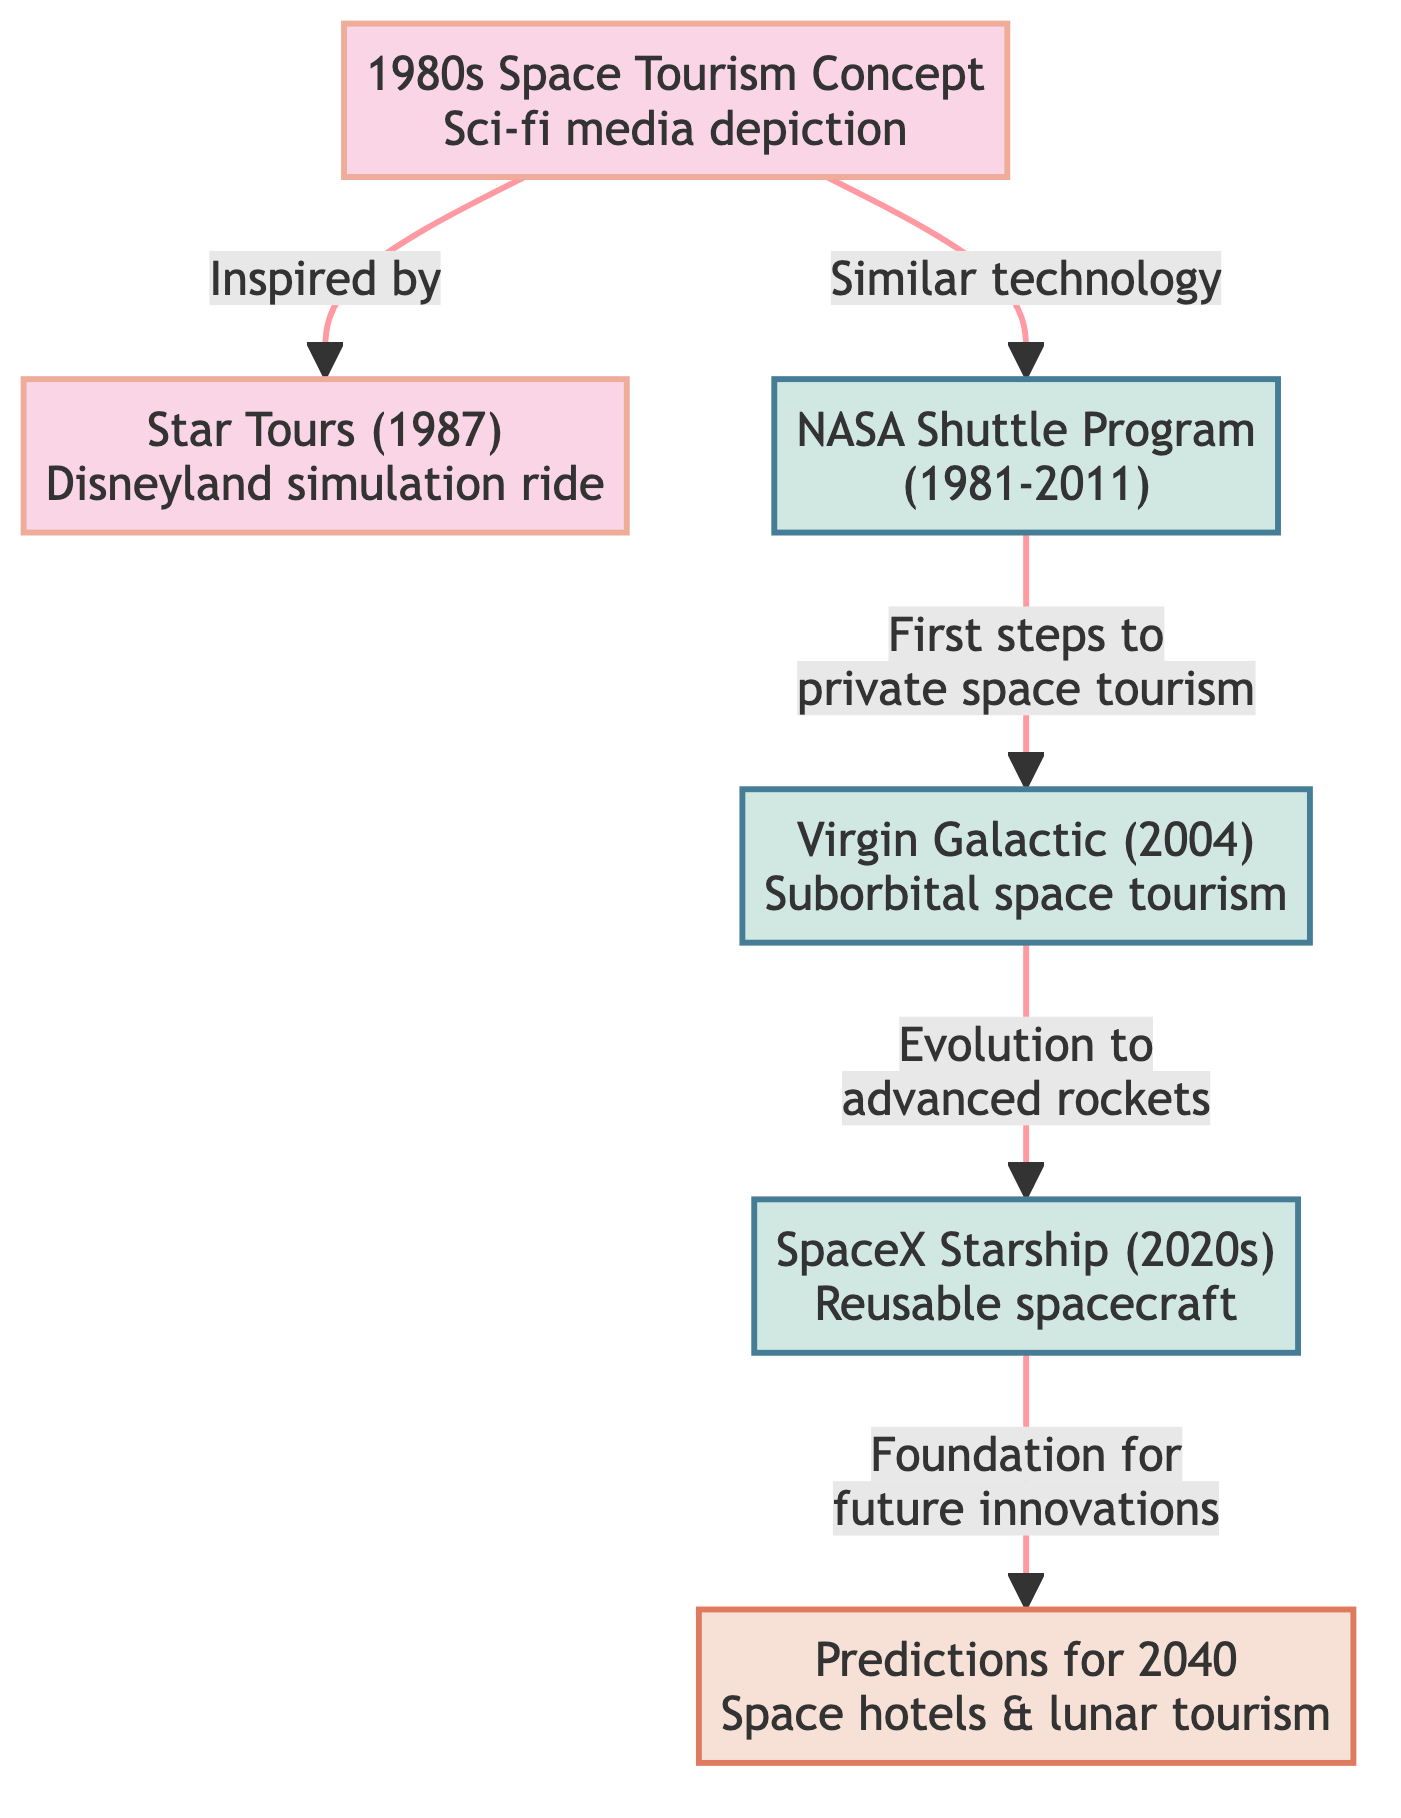What concept inspired Star Tours? The diagram indicates that the "1980s Space Tourism Concept" inspired "Star Tours (1987)". This is shown as a direct link from the first node to the second one.
Answer: 1980s Space Tourism Concept How many nodes represent real-world space tourism proposals? In the diagram, there are three nodes listed under real-world space tourism proposals: "NASA Shuttle Program", "Virgin Galactic", and "SpaceX Starship". Counting these nodes provides the answer.
Answer: 3 What is an example of a 1980s sci-fi media depiction of space tourism? The diagram specifically names "Star Tours (1987)" as an example of a 1980s sci-fi media depiction of space tourism. It is connected to the broader concept node.
Answer: Star Tours (1987) What type of future space tourism is predicted for 2040? According to the diagram, the predictions for 2040 include "space hotels & lunar tourism". This is noted in the "Predictions for 2040" future node.
Answer: Space hotels & lunar tourism Which node represents the evolution to advanced rockets? The diagram shows a link from "Virgin Galactic" to "SpaceX Starship", indicating that "Virgin Galactic" represents the evolution to advanced rockets.
Answer: Virgin Galactic What relationship exists between NASA Shuttle Program and private space tourism? The diagram states that the NASA Shuttle Program takes the first steps towards private space tourism, indicating a connection where NASA served as a precursor.
Answer: First steps to private space tourism Which real-world proposal is the foundation for future innovations? The diagram notes that "SpaceX Starship" is the foundation for future innovations, as indicated by the upward arrow linking it to predictions for 2040.
Answer: SpaceX Starship What color represents the nodes for future space tourism predictions? The "Predictions for 2040" node is represented with a specific color; the diagram marks this node with a fill color of "#f7e1d7". This identification is clear from the class definition for future nodes.
Answer: #f7e1d7 What concept is linked to the first space tourism simulation ride? The "1980s Space Tourism Concept" is linked to "Star Tours (1987)", indicating that this concept directly influenced the creation of the first space tourism simulation ride.
Answer: 1980s Space Tourism Concept 